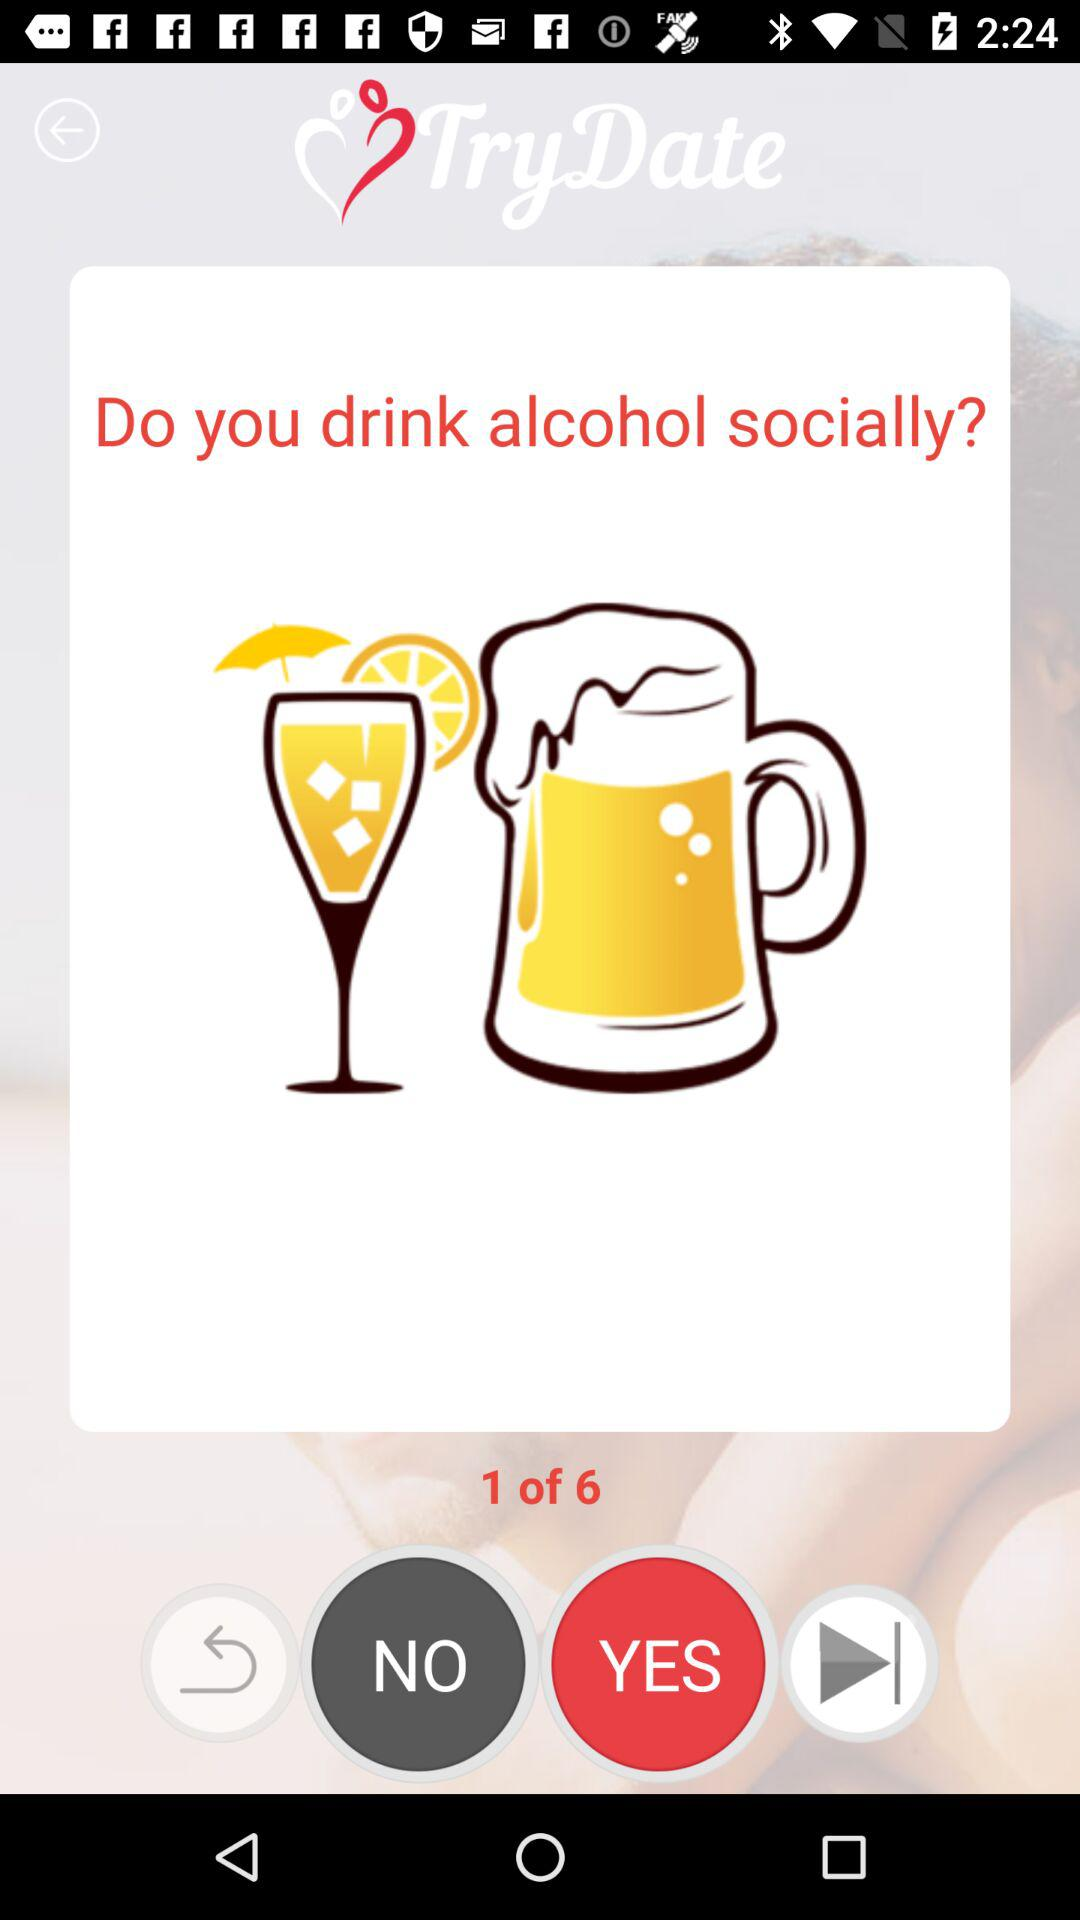What is the name of the application? The name of the application is "TryDate". 